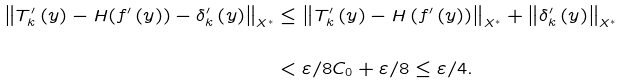Convert formula to latex. <formula><loc_0><loc_0><loc_500><loc_500>\left \| T _ { k } ^ { \prime } \left ( y \right ) - H ( f ^ { \prime } \left ( y \right ) ) - \delta _ { k } ^ { \prime } \left ( y \right ) \right \| _ { X ^ { \ast } } & \leq \left \| T _ { k } ^ { \prime } \left ( y \right ) - H \left ( f ^ { \prime } \left ( y \right ) \right ) \right \| _ { X ^ { \ast } } + \left \| \delta _ { k } ^ { \prime } \left ( y \right ) \right \| _ { X ^ { \ast } } \\ & \\ & < \varepsilon / 8 C _ { 0 } + \varepsilon / 8 \leq \varepsilon / 4 .</formula> 